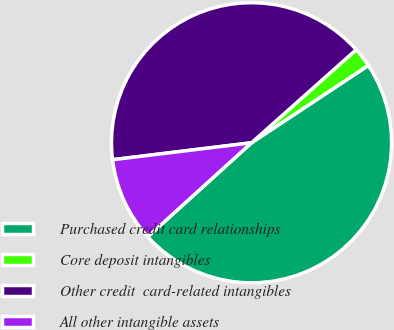Convert chart to OTSL. <chart><loc_0><loc_0><loc_500><loc_500><pie_chart><fcel>Purchased credit card relationships<fcel>Core deposit intangibles<fcel>Other credit  card-related intangibles<fcel>All other intangible assets<nl><fcel>47.59%<fcel>2.26%<fcel>40.36%<fcel>9.78%<nl></chart> 